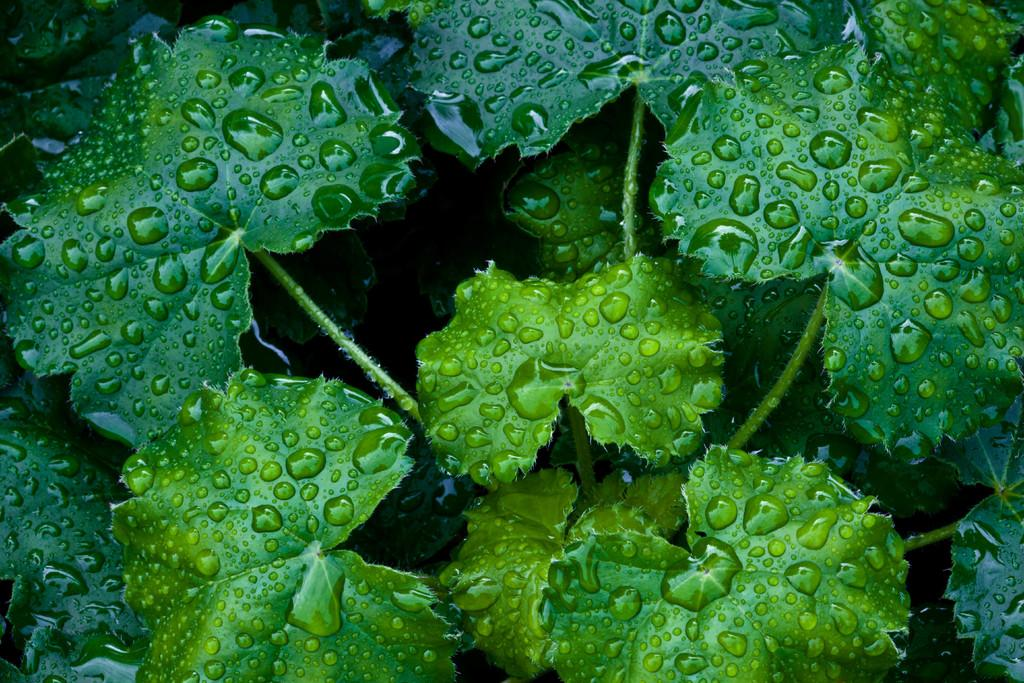What is the focus of the image? The image is a zoomed in view. What can be seen in the foreground of the image? There are green leaves in the foreground. What else is visible in the image? The stems of the plants are visible. Can you describe the appearance of the leaves in the image? Droplets of water are present on the leaves. How much debt is represented by the droplets of water on the leaves in the image? The image does not depict any debt; it shows droplets of water on leaves. What type of pain can be seen on the leaves in the image? There is no pain visible on the leaves in the image; they appear to be healthy and have droplets of water on them. 